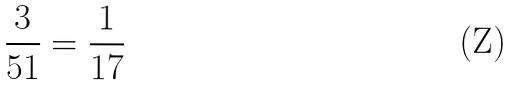Convert formula to latex. <formula><loc_0><loc_0><loc_500><loc_500>\frac { 3 } { 5 1 } = \frac { 1 } { 1 7 }</formula> 